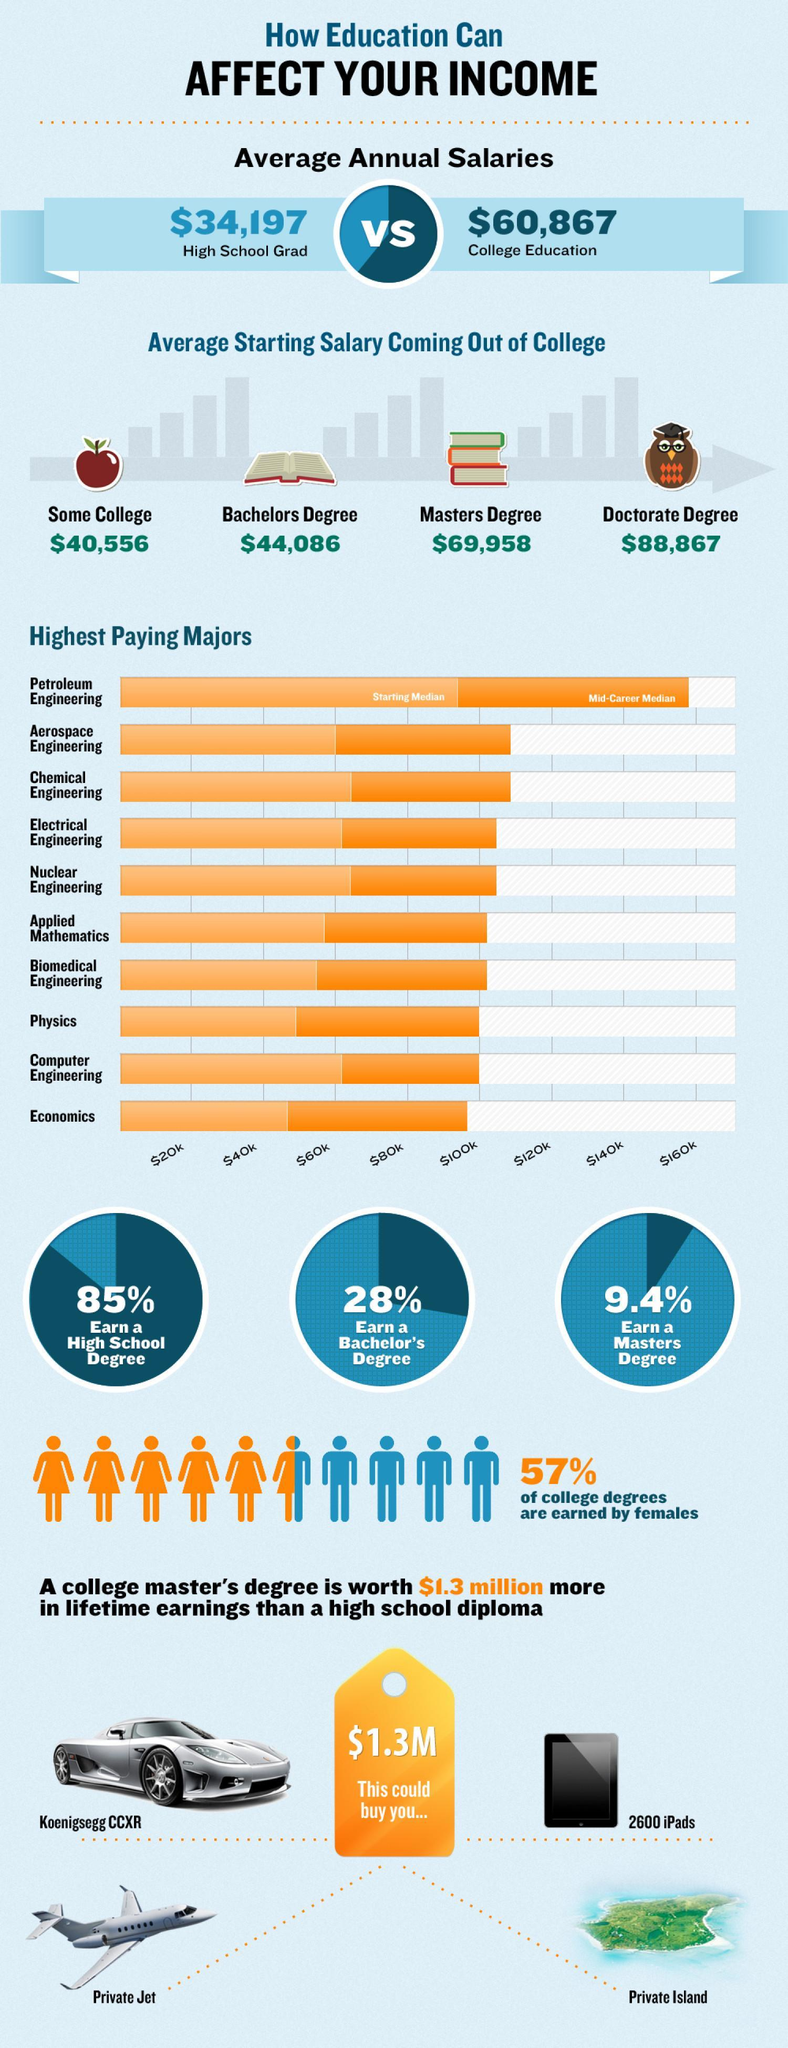Which is the highest paid college majors?
Answer the question with a short phrase. Petroleum Engineering What is the average starting salary for freshers with a doctorate degree? $88,867 Which is the second highest paid college majors? Aerospace Engineering What is the average starting salary for freshers with a Masters degree? $69,958 What percentage of the students earn a high school degree? 85% What is the average starting salary for freshers with a Bachelors degree? $44,086 What percentage of the students earn a masters degree? 9.4% What percentage of the college degrees are earned by males? 43% 